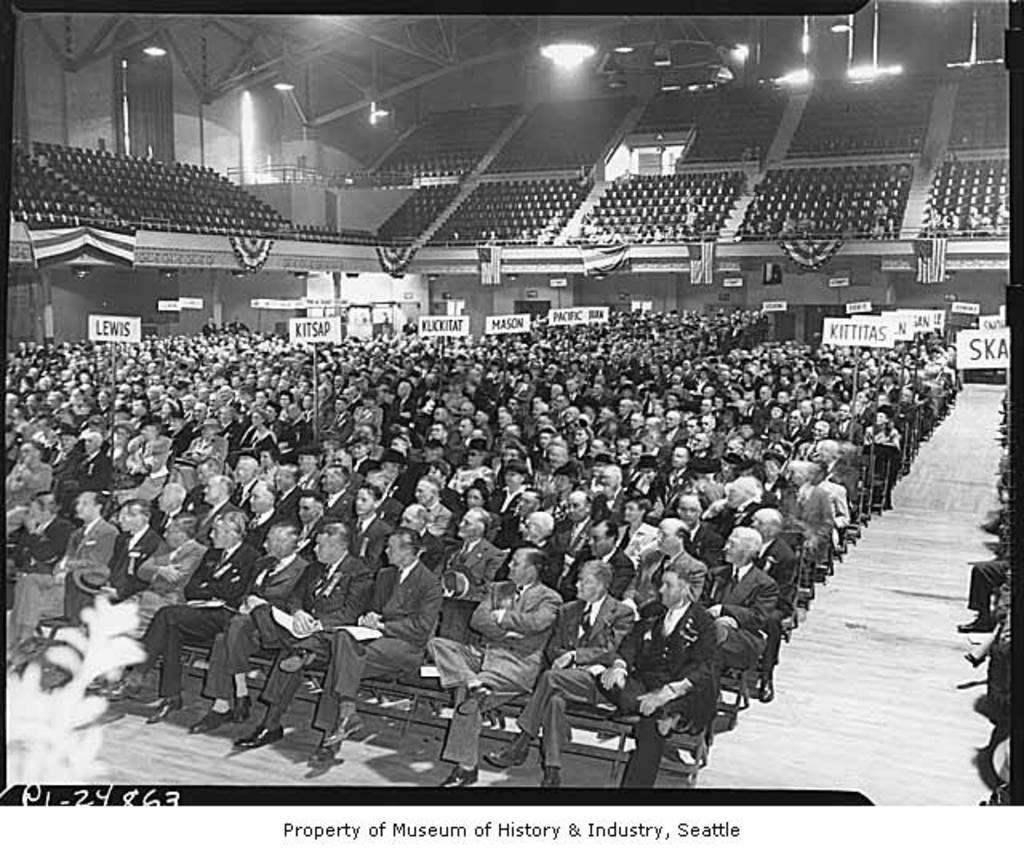In one or two sentences, can you explain what this image depicts? In this image I can see a crow is sitting on the chairs and a staircase. In the background I can see boards, fence, lights, wall and seats. This image is taken may be in an auditorium hall during night. 